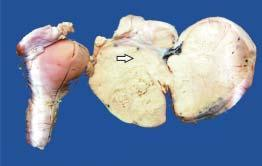does specimen of the uterus, cervix and adnexa show enlarged ovarian mass on one side which on cut section is solid, grey-white and firm?
Answer the question using a single word or phrase. Yes 